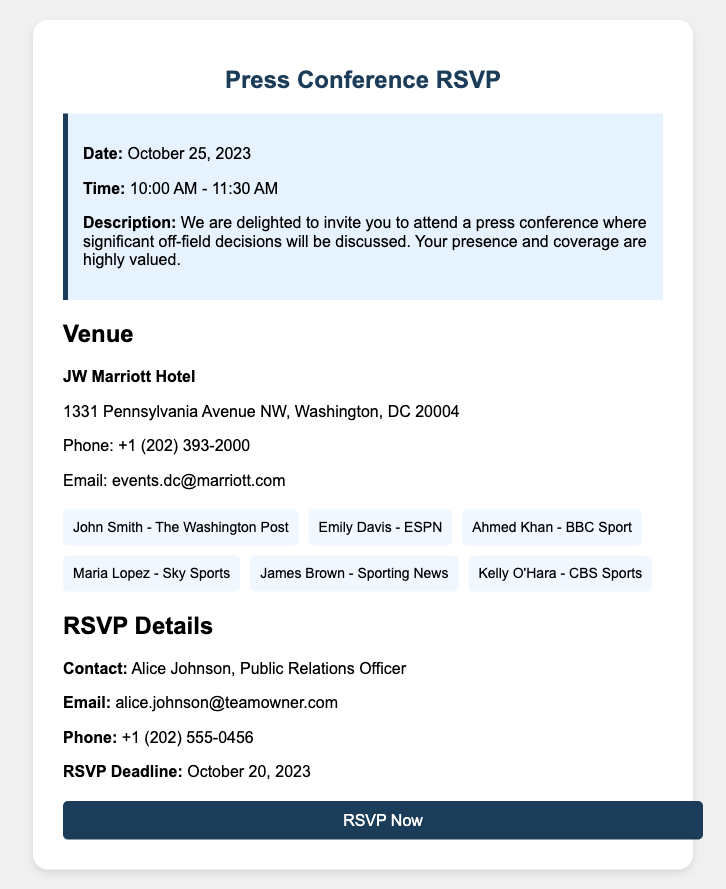What is the date of the press conference? The date is provided in the event details of the document.
Answer: October 25, 2023 What is the duration of the press conference? The start and end times are mentioned, indicating the duration of the event.
Answer: 1 hour 30 minutes Where is the venue located? The document specifies the venue details including the name and address.
Answer: JW Marriott Hotel, 1331 Pennsylvania Avenue NW, Washington, DC 20004 Who is the contact person for RSVPs? The document states the contact information under RSVP details.
Answer: Alice Johnson What is the RSVP deadline? The document explicitly mentions the deadline for RSVPs.
Answer: October 20, 2023 Which media personnel are attending? The names of the attending media personnel are listed under the attendees section.
Answer: John Smith, Emily Davis, Ahmed Khan, Maria Lopez, James Brown, Kelly O'Hara How many media personnel are listed as attendees? The document provides a list of names showing the total count of attendees.
Answer: 6 What is the email address of the RSVP contact? The email address is given under the RSVP details for the contact person.
Answer: alice.johnson@teamowner.com What time does the press conference start? The start time is mentioned in the event details of the document.
Answer: 10:00 AM 